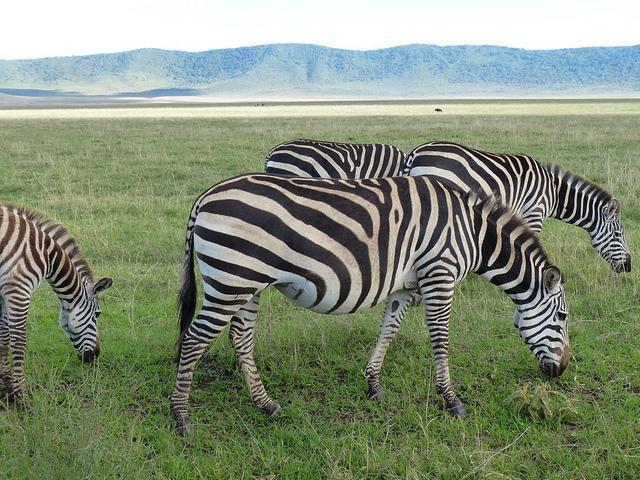How many zebras are in the photo?
Give a very brief answer. 4. How many propellers does the airplane have?
Give a very brief answer. 0. 